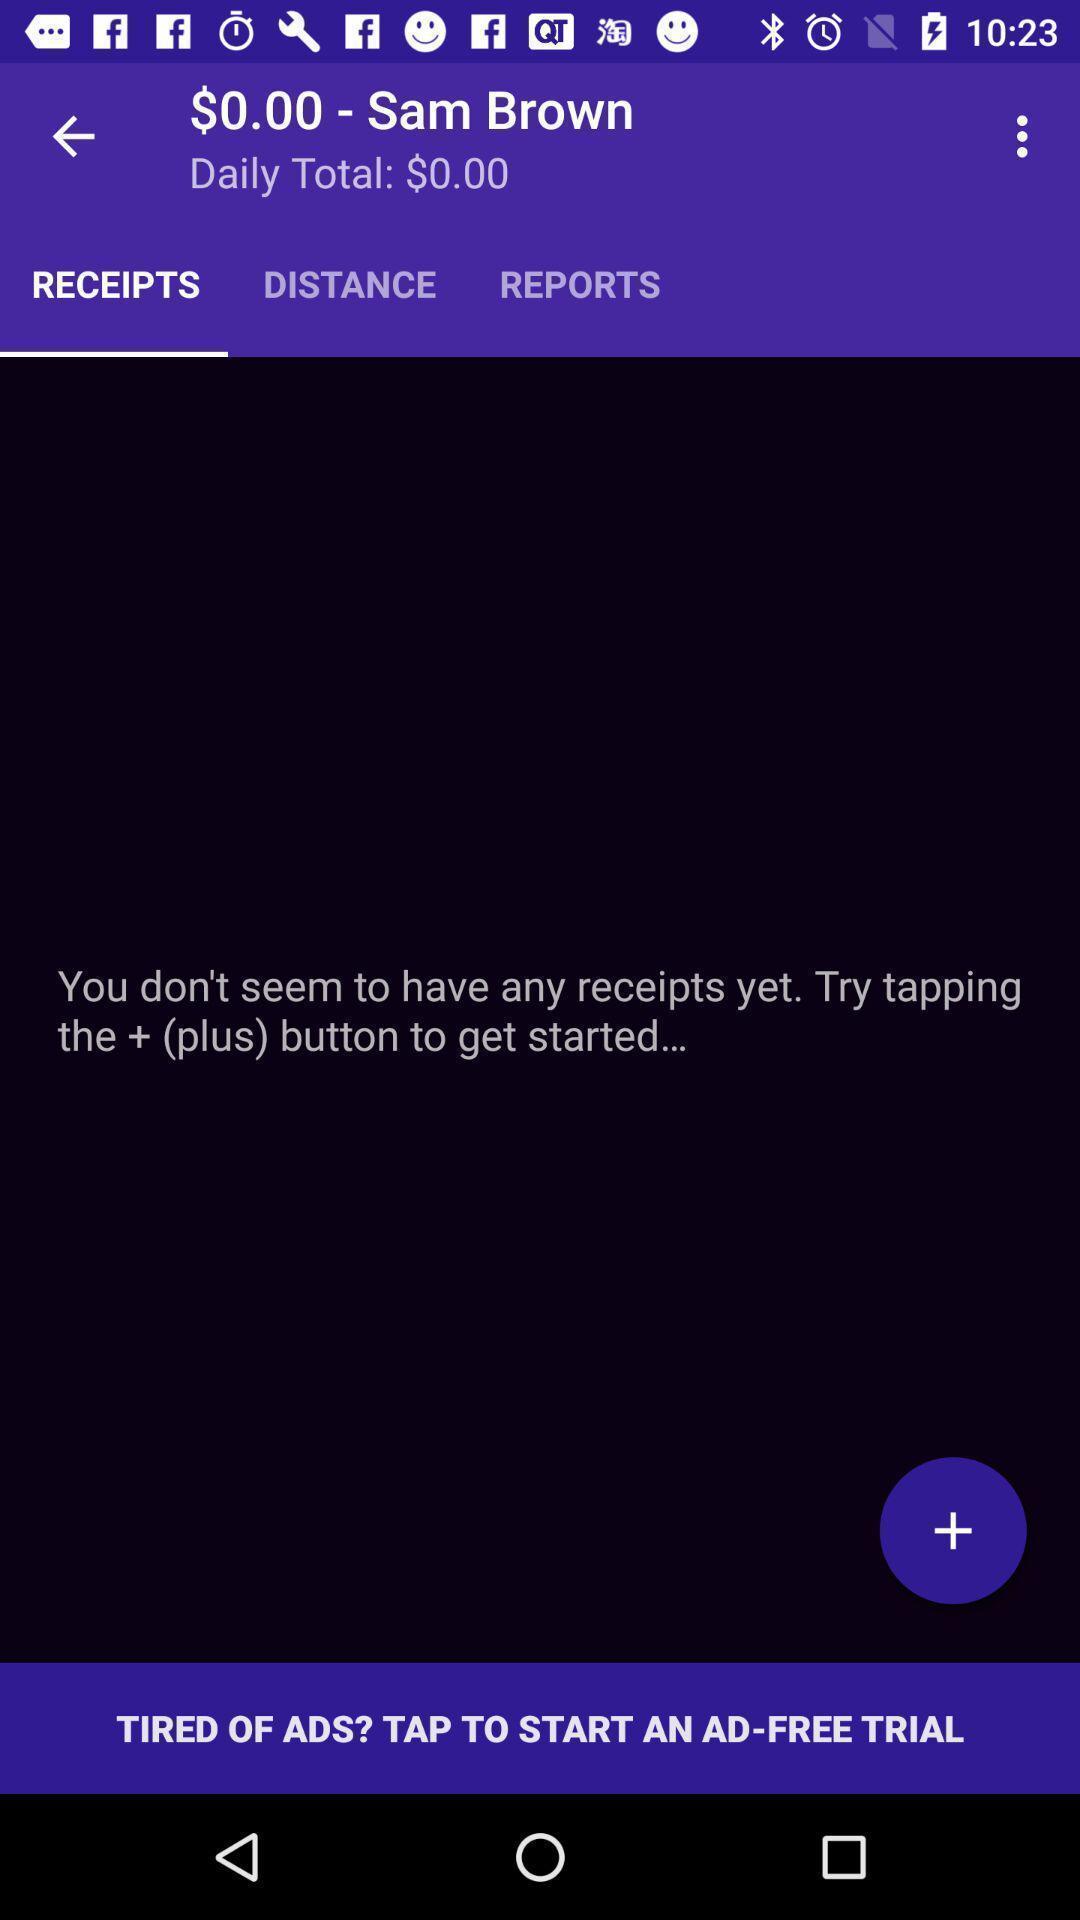Provide a textual representation of this image. Screen showing receipts. 